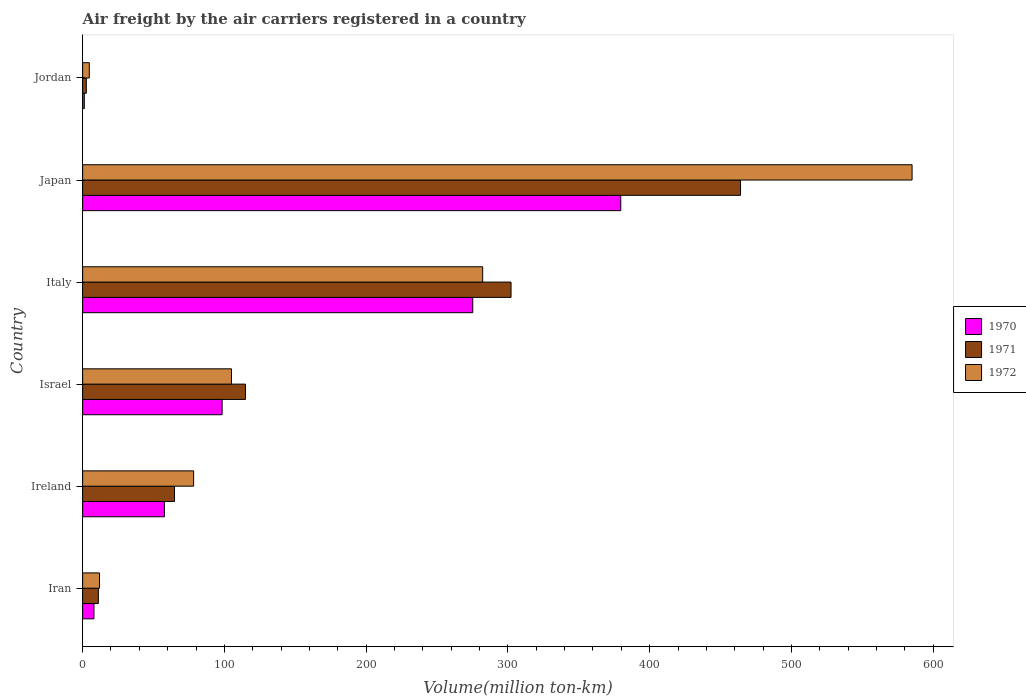Are the number of bars on each tick of the Y-axis equal?
Provide a succinct answer. Yes. How many bars are there on the 2nd tick from the bottom?
Keep it short and to the point. 3. What is the label of the 6th group of bars from the top?
Your answer should be compact. Iran. What is the volume of the air carriers in 1970 in Israel?
Provide a short and direct response. 98.4. Across all countries, what is the maximum volume of the air carriers in 1971?
Provide a short and direct response. 464.1. Across all countries, what is the minimum volume of the air carriers in 1972?
Your answer should be very brief. 4.7. In which country was the volume of the air carriers in 1970 maximum?
Your response must be concise. Japan. In which country was the volume of the air carriers in 1971 minimum?
Offer a very short reply. Jordan. What is the total volume of the air carriers in 1970 in the graph?
Your response must be concise. 820.1. What is the difference between the volume of the air carriers in 1971 in Iran and that in Japan?
Offer a very short reply. -453. What is the difference between the volume of the air carriers in 1971 in Israel and the volume of the air carriers in 1970 in Iran?
Your answer should be compact. 106.9. What is the average volume of the air carriers in 1970 per country?
Offer a terse response. 136.68. What is the difference between the volume of the air carriers in 1970 and volume of the air carriers in 1971 in Jordan?
Provide a succinct answer. -1.4. What is the ratio of the volume of the air carriers in 1970 in Ireland to that in Jordan?
Make the answer very short. 48.08. Is the volume of the air carriers in 1972 in Ireland less than that in Italy?
Your answer should be very brief. Yes. What is the difference between the highest and the second highest volume of the air carriers in 1970?
Provide a succinct answer. 104.4. What is the difference between the highest and the lowest volume of the air carriers in 1972?
Your response must be concise. 580.4. Is it the case that in every country, the sum of the volume of the air carriers in 1972 and volume of the air carriers in 1970 is greater than the volume of the air carriers in 1971?
Provide a short and direct response. Yes. How many bars are there?
Your response must be concise. 18. Are all the bars in the graph horizontal?
Keep it short and to the point. Yes. What is the difference between two consecutive major ticks on the X-axis?
Ensure brevity in your answer.  100. Are the values on the major ticks of X-axis written in scientific E-notation?
Provide a succinct answer. No. Does the graph contain any zero values?
Provide a succinct answer. No. How many legend labels are there?
Make the answer very short. 3. What is the title of the graph?
Give a very brief answer. Air freight by the air carriers registered in a country. What is the label or title of the X-axis?
Make the answer very short. Volume(million ton-km). What is the Volume(million ton-km) of 1970 in Iran?
Your answer should be very brief. 8. What is the Volume(million ton-km) of 1971 in Iran?
Offer a very short reply. 11.1. What is the Volume(million ton-km) of 1972 in Iran?
Your answer should be compact. 11.9. What is the Volume(million ton-km) of 1970 in Ireland?
Make the answer very short. 57.7. What is the Volume(million ton-km) of 1971 in Ireland?
Your answer should be very brief. 64.8. What is the Volume(million ton-km) of 1972 in Ireland?
Ensure brevity in your answer.  78.3. What is the Volume(million ton-km) of 1970 in Israel?
Provide a succinct answer. 98.4. What is the Volume(million ton-km) in 1971 in Israel?
Offer a terse response. 114.9. What is the Volume(million ton-km) in 1972 in Israel?
Your response must be concise. 105. What is the Volume(million ton-km) in 1970 in Italy?
Give a very brief answer. 275.2. What is the Volume(million ton-km) in 1971 in Italy?
Provide a short and direct response. 302.2. What is the Volume(million ton-km) of 1972 in Italy?
Ensure brevity in your answer.  282.2. What is the Volume(million ton-km) of 1970 in Japan?
Make the answer very short. 379.6. What is the Volume(million ton-km) of 1971 in Japan?
Your answer should be very brief. 464.1. What is the Volume(million ton-km) in 1972 in Japan?
Provide a short and direct response. 585.1. What is the Volume(million ton-km) of 1970 in Jordan?
Ensure brevity in your answer.  1.2. What is the Volume(million ton-km) of 1971 in Jordan?
Make the answer very short. 2.6. What is the Volume(million ton-km) of 1972 in Jordan?
Make the answer very short. 4.7. Across all countries, what is the maximum Volume(million ton-km) in 1970?
Your answer should be very brief. 379.6. Across all countries, what is the maximum Volume(million ton-km) in 1971?
Give a very brief answer. 464.1. Across all countries, what is the maximum Volume(million ton-km) of 1972?
Ensure brevity in your answer.  585.1. Across all countries, what is the minimum Volume(million ton-km) of 1970?
Keep it short and to the point. 1.2. Across all countries, what is the minimum Volume(million ton-km) in 1971?
Ensure brevity in your answer.  2.6. Across all countries, what is the minimum Volume(million ton-km) of 1972?
Provide a short and direct response. 4.7. What is the total Volume(million ton-km) of 1970 in the graph?
Offer a very short reply. 820.1. What is the total Volume(million ton-km) of 1971 in the graph?
Your answer should be very brief. 959.7. What is the total Volume(million ton-km) of 1972 in the graph?
Offer a very short reply. 1067.2. What is the difference between the Volume(million ton-km) in 1970 in Iran and that in Ireland?
Your answer should be compact. -49.7. What is the difference between the Volume(million ton-km) of 1971 in Iran and that in Ireland?
Make the answer very short. -53.7. What is the difference between the Volume(million ton-km) in 1972 in Iran and that in Ireland?
Offer a very short reply. -66.4. What is the difference between the Volume(million ton-km) of 1970 in Iran and that in Israel?
Provide a succinct answer. -90.4. What is the difference between the Volume(million ton-km) of 1971 in Iran and that in Israel?
Your answer should be very brief. -103.8. What is the difference between the Volume(million ton-km) in 1972 in Iran and that in Israel?
Ensure brevity in your answer.  -93.1. What is the difference between the Volume(million ton-km) of 1970 in Iran and that in Italy?
Provide a succinct answer. -267.2. What is the difference between the Volume(million ton-km) of 1971 in Iran and that in Italy?
Keep it short and to the point. -291.1. What is the difference between the Volume(million ton-km) in 1972 in Iran and that in Italy?
Provide a succinct answer. -270.3. What is the difference between the Volume(million ton-km) in 1970 in Iran and that in Japan?
Keep it short and to the point. -371.6. What is the difference between the Volume(million ton-km) in 1971 in Iran and that in Japan?
Offer a terse response. -453. What is the difference between the Volume(million ton-km) of 1972 in Iran and that in Japan?
Offer a terse response. -573.2. What is the difference between the Volume(million ton-km) of 1970 in Iran and that in Jordan?
Your answer should be very brief. 6.8. What is the difference between the Volume(million ton-km) of 1971 in Iran and that in Jordan?
Offer a very short reply. 8.5. What is the difference between the Volume(million ton-km) in 1972 in Iran and that in Jordan?
Your answer should be very brief. 7.2. What is the difference between the Volume(million ton-km) of 1970 in Ireland and that in Israel?
Your answer should be very brief. -40.7. What is the difference between the Volume(million ton-km) in 1971 in Ireland and that in Israel?
Offer a very short reply. -50.1. What is the difference between the Volume(million ton-km) in 1972 in Ireland and that in Israel?
Offer a very short reply. -26.7. What is the difference between the Volume(million ton-km) in 1970 in Ireland and that in Italy?
Give a very brief answer. -217.5. What is the difference between the Volume(million ton-km) of 1971 in Ireland and that in Italy?
Provide a succinct answer. -237.4. What is the difference between the Volume(million ton-km) of 1972 in Ireland and that in Italy?
Keep it short and to the point. -203.9. What is the difference between the Volume(million ton-km) of 1970 in Ireland and that in Japan?
Make the answer very short. -321.9. What is the difference between the Volume(million ton-km) of 1971 in Ireland and that in Japan?
Provide a succinct answer. -399.3. What is the difference between the Volume(million ton-km) of 1972 in Ireland and that in Japan?
Make the answer very short. -506.8. What is the difference between the Volume(million ton-km) of 1970 in Ireland and that in Jordan?
Ensure brevity in your answer.  56.5. What is the difference between the Volume(million ton-km) in 1971 in Ireland and that in Jordan?
Your answer should be compact. 62.2. What is the difference between the Volume(million ton-km) of 1972 in Ireland and that in Jordan?
Give a very brief answer. 73.6. What is the difference between the Volume(million ton-km) in 1970 in Israel and that in Italy?
Offer a very short reply. -176.8. What is the difference between the Volume(million ton-km) in 1971 in Israel and that in Italy?
Make the answer very short. -187.3. What is the difference between the Volume(million ton-km) in 1972 in Israel and that in Italy?
Offer a terse response. -177.2. What is the difference between the Volume(million ton-km) in 1970 in Israel and that in Japan?
Offer a terse response. -281.2. What is the difference between the Volume(million ton-km) of 1971 in Israel and that in Japan?
Your answer should be compact. -349.2. What is the difference between the Volume(million ton-km) in 1972 in Israel and that in Japan?
Give a very brief answer. -480.1. What is the difference between the Volume(million ton-km) in 1970 in Israel and that in Jordan?
Provide a short and direct response. 97.2. What is the difference between the Volume(million ton-km) in 1971 in Israel and that in Jordan?
Your answer should be very brief. 112.3. What is the difference between the Volume(million ton-km) in 1972 in Israel and that in Jordan?
Provide a short and direct response. 100.3. What is the difference between the Volume(million ton-km) in 1970 in Italy and that in Japan?
Offer a very short reply. -104.4. What is the difference between the Volume(million ton-km) in 1971 in Italy and that in Japan?
Your answer should be compact. -161.9. What is the difference between the Volume(million ton-km) in 1972 in Italy and that in Japan?
Provide a succinct answer. -302.9. What is the difference between the Volume(million ton-km) of 1970 in Italy and that in Jordan?
Your answer should be compact. 274. What is the difference between the Volume(million ton-km) in 1971 in Italy and that in Jordan?
Your response must be concise. 299.6. What is the difference between the Volume(million ton-km) in 1972 in Italy and that in Jordan?
Make the answer very short. 277.5. What is the difference between the Volume(million ton-km) in 1970 in Japan and that in Jordan?
Your answer should be compact. 378.4. What is the difference between the Volume(million ton-km) in 1971 in Japan and that in Jordan?
Give a very brief answer. 461.5. What is the difference between the Volume(million ton-km) of 1972 in Japan and that in Jordan?
Keep it short and to the point. 580.4. What is the difference between the Volume(million ton-km) of 1970 in Iran and the Volume(million ton-km) of 1971 in Ireland?
Keep it short and to the point. -56.8. What is the difference between the Volume(million ton-km) of 1970 in Iran and the Volume(million ton-km) of 1972 in Ireland?
Offer a very short reply. -70.3. What is the difference between the Volume(million ton-km) of 1971 in Iran and the Volume(million ton-km) of 1972 in Ireland?
Give a very brief answer. -67.2. What is the difference between the Volume(million ton-km) of 1970 in Iran and the Volume(million ton-km) of 1971 in Israel?
Keep it short and to the point. -106.9. What is the difference between the Volume(million ton-km) of 1970 in Iran and the Volume(million ton-km) of 1972 in Israel?
Give a very brief answer. -97. What is the difference between the Volume(million ton-km) in 1971 in Iran and the Volume(million ton-km) in 1972 in Israel?
Provide a short and direct response. -93.9. What is the difference between the Volume(million ton-km) in 1970 in Iran and the Volume(million ton-km) in 1971 in Italy?
Give a very brief answer. -294.2. What is the difference between the Volume(million ton-km) in 1970 in Iran and the Volume(million ton-km) in 1972 in Italy?
Keep it short and to the point. -274.2. What is the difference between the Volume(million ton-km) of 1971 in Iran and the Volume(million ton-km) of 1972 in Italy?
Offer a very short reply. -271.1. What is the difference between the Volume(million ton-km) of 1970 in Iran and the Volume(million ton-km) of 1971 in Japan?
Provide a succinct answer. -456.1. What is the difference between the Volume(million ton-km) in 1970 in Iran and the Volume(million ton-km) in 1972 in Japan?
Your answer should be very brief. -577.1. What is the difference between the Volume(million ton-km) of 1971 in Iran and the Volume(million ton-km) of 1972 in Japan?
Your answer should be compact. -574. What is the difference between the Volume(million ton-km) of 1970 in Ireland and the Volume(million ton-km) of 1971 in Israel?
Make the answer very short. -57.2. What is the difference between the Volume(million ton-km) of 1970 in Ireland and the Volume(million ton-km) of 1972 in Israel?
Your response must be concise. -47.3. What is the difference between the Volume(million ton-km) in 1971 in Ireland and the Volume(million ton-km) in 1972 in Israel?
Give a very brief answer. -40.2. What is the difference between the Volume(million ton-km) of 1970 in Ireland and the Volume(million ton-km) of 1971 in Italy?
Your answer should be very brief. -244.5. What is the difference between the Volume(million ton-km) in 1970 in Ireland and the Volume(million ton-km) in 1972 in Italy?
Give a very brief answer. -224.5. What is the difference between the Volume(million ton-km) in 1971 in Ireland and the Volume(million ton-km) in 1972 in Italy?
Your answer should be very brief. -217.4. What is the difference between the Volume(million ton-km) of 1970 in Ireland and the Volume(million ton-km) of 1971 in Japan?
Your answer should be very brief. -406.4. What is the difference between the Volume(million ton-km) in 1970 in Ireland and the Volume(million ton-km) in 1972 in Japan?
Provide a short and direct response. -527.4. What is the difference between the Volume(million ton-km) of 1971 in Ireland and the Volume(million ton-km) of 1972 in Japan?
Offer a terse response. -520.3. What is the difference between the Volume(million ton-km) of 1970 in Ireland and the Volume(million ton-km) of 1971 in Jordan?
Keep it short and to the point. 55.1. What is the difference between the Volume(million ton-km) of 1970 in Ireland and the Volume(million ton-km) of 1972 in Jordan?
Offer a very short reply. 53. What is the difference between the Volume(million ton-km) of 1971 in Ireland and the Volume(million ton-km) of 1972 in Jordan?
Provide a succinct answer. 60.1. What is the difference between the Volume(million ton-km) in 1970 in Israel and the Volume(million ton-km) in 1971 in Italy?
Keep it short and to the point. -203.8. What is the difference between the Volume(million ton-km) of 1970 in Israel and the Volume(million ton-km) of 1972 in Italy?
Make the answer very short. -183.8. What is the difference between the Volume(million ton-km) of 1971 in Israel and the Volume(million ton-km) of 1972 in Italy?
Provide a short and direct response. -167.3. What is the difference between the Volume(million ton-km) in 1970 in Israel and the Volume(million ton-km) in 1971 in Japan?
Your answer should be very brief. -365.7. What is the difference between the Volume(million ton-km) in 1970 in Israel and the Volume(million ton-km) in 1972 in Japan?
Give a very brief answer. -486.7. What is the difference between the Volume(million ton-km) of 1971 in Israel and the Volume(million ton-km) of 1972 in Japan?
Offer a very short reply. -470.2. What is the difference between the Volume(million ton-km) of 1970 in Israel and the Volume(million ton-km) of 1971 in Jordan?
Your response must be concise. 95.8. What is the difference between the Volume(million ton-km) in 1970 in Israel and the Volume(million ton-km) in 1972 in Jordan?
Your answer should be very brief. 93.7. What is the difference between the Volume(million ton-km) in 1971 in Israel and the Volume(million ton-km) in 1972 in Jordan?
Give a very brief answer. 110.2. What is the difference between the Volume(million ton-km) of 1970 in Italy and the Volume(million ton-km) of 1971 in Japan?
Your answer should be very brief. -188.9. What is the difference between the Volume(million ton-km) of 1970 in Italy and the Volume(million ton-km) of 1972 in Japan?
Your answer should be compact. -309.9. What is the difference between the Volume(million ton-km) in 1971 in Italy and the Volume(million ton-km) in 1972 in Japan?
Keep it short and to the point. -282.9. What is the difference between the Volume(million ton-km) of 1970 in Italy and the Volume(million ton-km) of 1971 in Jordan?
Keep it short and to the point. 272.6. What is the difference between the Volume(million ton-km) in 1970 in Italy and the Volume(million ton-km) in 1972 in Jordan?
Make the answer very short. 270.5. What is the difference between the Volume(million ton-km) in 1971 in Italy and the Volume(million ton-km) in 1972 in Jordan?
Give a very brief answer. 297.5. What is the difference between the Volume(million ton-km) in 1970 in Japan and the Volume(million ton-km) in 1971 in Jordan?
Your answer should be very brief. 377. What is the difference between the Volume(million ton-km) of 1970 in Japan and the Volume(million ton-km) of 1972 in Jordan?
Provide a short and direct response. 374.9. What is the difference between the Volume(million ton-km) in 1971 in Japan and the Volume(million ton-km) in 1972 in Jordan?
Your response must be concise. 459.4. What is the average Volume(million ton-km) of 1970 per country?
Ensure brevity in your answer.  136.68. What is the average Volume(million ton-km) in 1971 per country?
Your answer should be compact. 159.95. What is the average Volume(million ton-km) of 1972 per country?
Give a very brief answer. 177.87. What is the difference between the Volume(million ton-km) in 1970 and Volume(million ton-km) in 1971 in Iran?
Ensure brevity in your answer.  -3.1. What is the difference between the Volume(million ton-km) in 1971 and Volume(million ton-km) in 1972 in Iran?
Your response must be concise. -0.8. What is the difference between the Volume(million ton-km) in 1970 and Volume(million ton-km) in 1971 in Ireland?
Ensure brevity in your answer.  -7.1. What is the difference between the Volume(million ton-km) of 1970 and Volume(million ton-km) of 1972 in Ireland?
Ensure brevity in your answer.  -20.6. What is the difference between the Volume(million ton-km) of 1970 and Volume(million ton-km) of 1971 in Israel?
Give a very brief answer. -16.5. What is the difference between the Volume(million ton-km) of 1971 and Volume(million ton-km) of 1972 in Israel?
Your answer should be very brief. 9.9. What is the difference between the Volume(million ton-km) of 1970 and Volume(million ton-km) of 1972 in Italy?
Offer a very short reply. -7. What is the difference between the Volume(million ton-km) in 1971 and Volume(million ton-km) in 1972 in Italy?
Give a very brief answer. 20. What is the difference between the Volume(million ton-km) in 1970 and Volume(million ton-km) in 1971 in Japan?
Your answer should be compact. -84.5. What is the difference between the Volume(million ton-km) in 1970 and Volume(million ton-km) in 1972 in Japan?
Ensure brevity in your answer.  -205.5. What is the difference between the Volume(million ton-km) of 1971 and Volume(million ton-km) of 1972 in Japan?
Your response must be concise. -121. What is the difference between the Volume(million ton-km) of 1970 and Volume(million ton-km) of 1971 in Jordan?
Your response must be concise. -1.4. What is the difference between the Volume(million ton-km) in 1970 and Volume(million ton-km) in 1972 in Jordan?
Your response must be concise. -3.5. What is the ratio of the Volume(million ton-km) in 1970 in Iran to that in Ireland?
Offer a terse response. 0.14. What is the ratio of the Volume(million ton-km) of 1971 in Iran to that in Ireland?
Make the answer very short. 0.17. What is the ratio of the Volume(million ton-km) of 1972 in Iran to that in Ireland?
Ensure brevity in your answer.  0.15. What is the ratio of the Volume(million ton-km) in 1970 in Iran to that in Israel?
Ensure brevity in your answer.  0.08. What is the ratio of the Volume(million ton-km) of 1971 in Iran to that in Israel?
Make the answer very short. 0.1. What is the ratio of the Volume(million ton-km) of 1972 in Iran to that in Israel?
Give a very brief answer. 0.11. What is the ratio of the Volume(million ton-km) of 1970 in Iran to that in Italy?
Make the answer very short. 0.03. What is the ratio of the Volume(million ton-km) of 1971 in Iran to that in Italy?
Your answer should be compact. 0.04. What is the ratio of the Volume(million ton-km) in 1972 in Iran to that in Italy?
Offer a very short reply. 0.04. What is the ratio of the Volume(million ton-km) in 1970 in Iran to that in Japan?
Make the answer very short. 0.02. What is the ratio of the Volume(million ton-km) of 1971 in Iran to that in Japan?
Keep it short and to the point. 0.02. What is the ratio of the Volume(million ton-km) of 1972 in Iran to that in Japan?
Offer a terse response. 0.02. What is the ratio of the Volume(million ton-km) in 1970 in Iran to that in Jordan?
Provide a short and direct response. 6.67. What is the ratio of the Volume(million ton-km) in 1971 in Iran to that in Jordan?
Make the answer very short. 4.27. What is the ratio of the Volume(million ton-km) in 1972 in Iran to that in Jordan?
Ensure brevity in your answer.  2.53. What is the ratio of the Volume(million ton-km) of 1970 in Ireland to that in Israel?
Ensure brevity in your answer.  0.59. What is the ratio of the Volume(million ton-km) in 1971 in Ireland to that in Israel?
Provide a succinct answer. 0.56. What is the ratio of the Volume(million ton-km) of 1972 in Ireland to that in Israel?
Provide a short and direct response. 0.75. What is the ratio of the Volume(million ton-km) in 1970 in Ireland to that in Italy?
Provide a short and direct response. 0.21. What is the ratio of the Volume(million ton-km) in 1971 in Ireland to that in Italy?
Ensure brevity in your answer.  0.21. What is the ratio of the Volume(million ton-km) in 1972 in Ireland to that in Italy?
Offer a very short reply. 0.28. What is the ratio of the Volume(million ton-km) in 1970 in Ireland to that in Japan?
Your response must be concise. 0.15. What is the ratio of the Volume(million ton-km) of 1971 in Ireland to that in Japan?
Offer a terse response. 0.14. What is the ratio of the Volume(million ton-km) in 1972 in Ireland to that in Japan?
Your answer should be very brief. 0.13. What is the ratio of the Volume(million ton-km) in 1970 in Ireland to that in Jordan?
Provide a succinct answer. 48.08. What is the ratio of the Volume(million ton-km) in 1971 in Ireland to that in Jordan?
Provide a short and direct response. 24.92. What is the ratio of the Volume(million ton-km) of 1972 in Ireland to that in Jordan?
Provide a succinct answer. 16.66. What is the ratio of the Volume(million ton-km) of 1970 in Israel to that in Italy?
Offer a terse response. 0.36. What is the ratio of the Volume(million ton-km) in 1971 in Israel to that in Italy?
Your answer should be compact. 0.38. What is the ratio of the Volume(million ton-km) of 1972 in Israel to that in Italy?
Provide a short and direct response. 0.37. What is the ratio of the Volume(million ton-km) of 1970 in Israel to that in Japan?
Keep it short and to the point. 0.26. What is the ratio of the Volume(million ton-km) of 1971 in Israel to that in Japan?
Keep it short and to the point. 0.25. What is the ratio of the Volume(million ton-km) of 1972 in Israel to that in Japan?
Keep it short and to the point. 0.18. What is the ratio of the Volume(million ton-km) of 1970 in Israel to that in Jordan?
Offer a terse response. 82. What is the ratio of the Volume(million ton-km) of 1971 in Israel to that in Jordan?
Ensure brevity in your answer.  44.19. What is the ratio of the Volume(million ton-km) of 1972 in Israel to that in Jordan?
Provide a succinct answer. 22.34. What is the ratio of the Volume(million ton-km) of 1970 in Italy to that in Japan?
Offer a terse response. 0.72. What is the ratio of the Volume(million ton-km) of 1971 in Italy to that in Japan?
Keep it short and to the point. 0.65. What is the ratio of the Volume(million ton-km) in 1972 in Italy to that in Japan?
Provide a succinct answer. 0.48. What is the ratio of the Volume(million ton-km) of 1970 in Italy to that in Jordan?
Provide a succinct answer. 229.33. What is the ratio of the Volume(million ton-km) of 1971 in Italy to that in Jordan?
Ensure brevity in your answer.  116.23. What is the ratio of the Volume(million ton-km) of 1972 in Italy to that in Jordan?
Provide a succinct answer. 60.04. What is the ratio of the Volume(million ton-km) in 1970 in Japan to that in Jordan?
Offer a very short reply. 316.33. What is the ratio of the Volume(million ton-km) of 1971 in Japan to that in Jordan?
Provide a short and direct response. 178.5. What is the ratio of the Volume(million ton-km) in 1972 in Japan to that in Jordan?
Give a very brief answer. 124.49. What is the difference between the highest and the second highest Volume(million ton-km) of 1970?
Your answer should be compact. 104.4. What is the difference between the highest and the second highest Volume(million ton-km) in 1971?
Your response must be concise. 161.9. What is the difference between the highest and the second highest Volume(million ton-km) in 1972?
Keep it short and to the point. 302.9. What is the difference between the highest and the lowest Volume(million ton-km) in 1970?
Keep it short and to the point. 378.4. What is the difference between the highest and the lowest Volume(million ton-km) of 1971?
Make the answer very short. 461.5. What is the difference between the highest and the lowest Volume(million ton-km) of 1972?
Give a very brief answer. 580.4. 